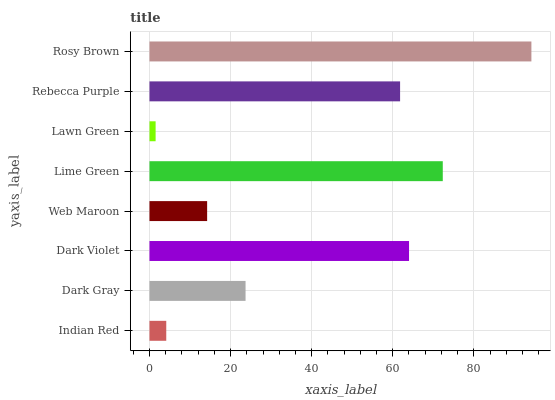Is Lawn Green the minimum?
Answer yes or no. Yes. Is Rosy Brown the maximum?
Answer yes or no. Yes. Is Dark Gray the minimum?
Answer yes or no. No. Is Dark Gray the maximum?
Answer yes or no. No. Is Dark Gray greater than Indian Red?
Answer yes or no. Yes. Is Indian Red less than Dark Gray?
Answer yes or no. Yes. Is Indian Red greater than Dark Gray?
Answer yes or no. No. Is Dark Gray less than Indian Red?
Answer yes or no. No. Is Rebecca Purple the high median?
Answer yes or no. Yes. Is Dark Gray the low median?
Answer yes or no. Yes. Is Dark Gray the high median?
Answer yes or no. No. Is Dark Violet the low median?
Answer yes or no. No. 